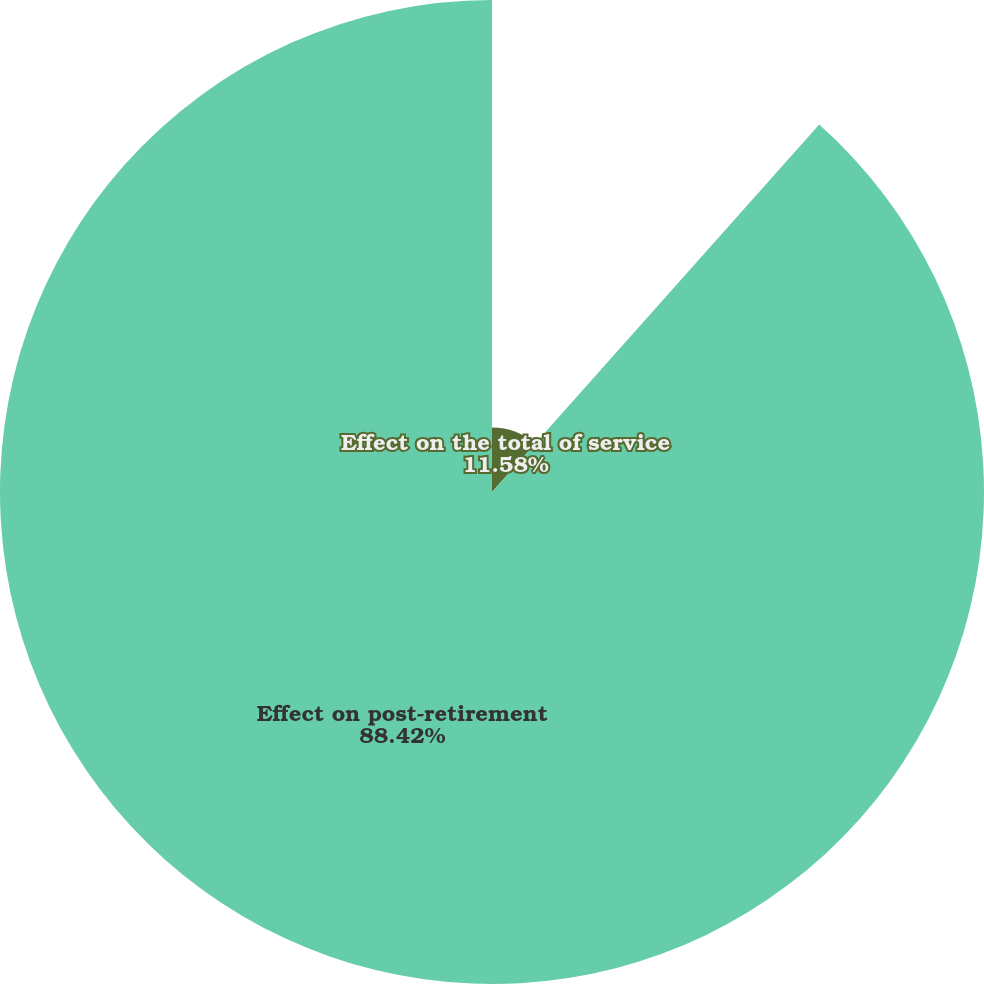<chart> <loc_0><loc_0><loc_500><loc_500><pie_chart><fcel>Effect on the total of service<fcel>Effect on post-retirement<nl><fcel>11.58%<fcel>88.42%<nl></chart> 